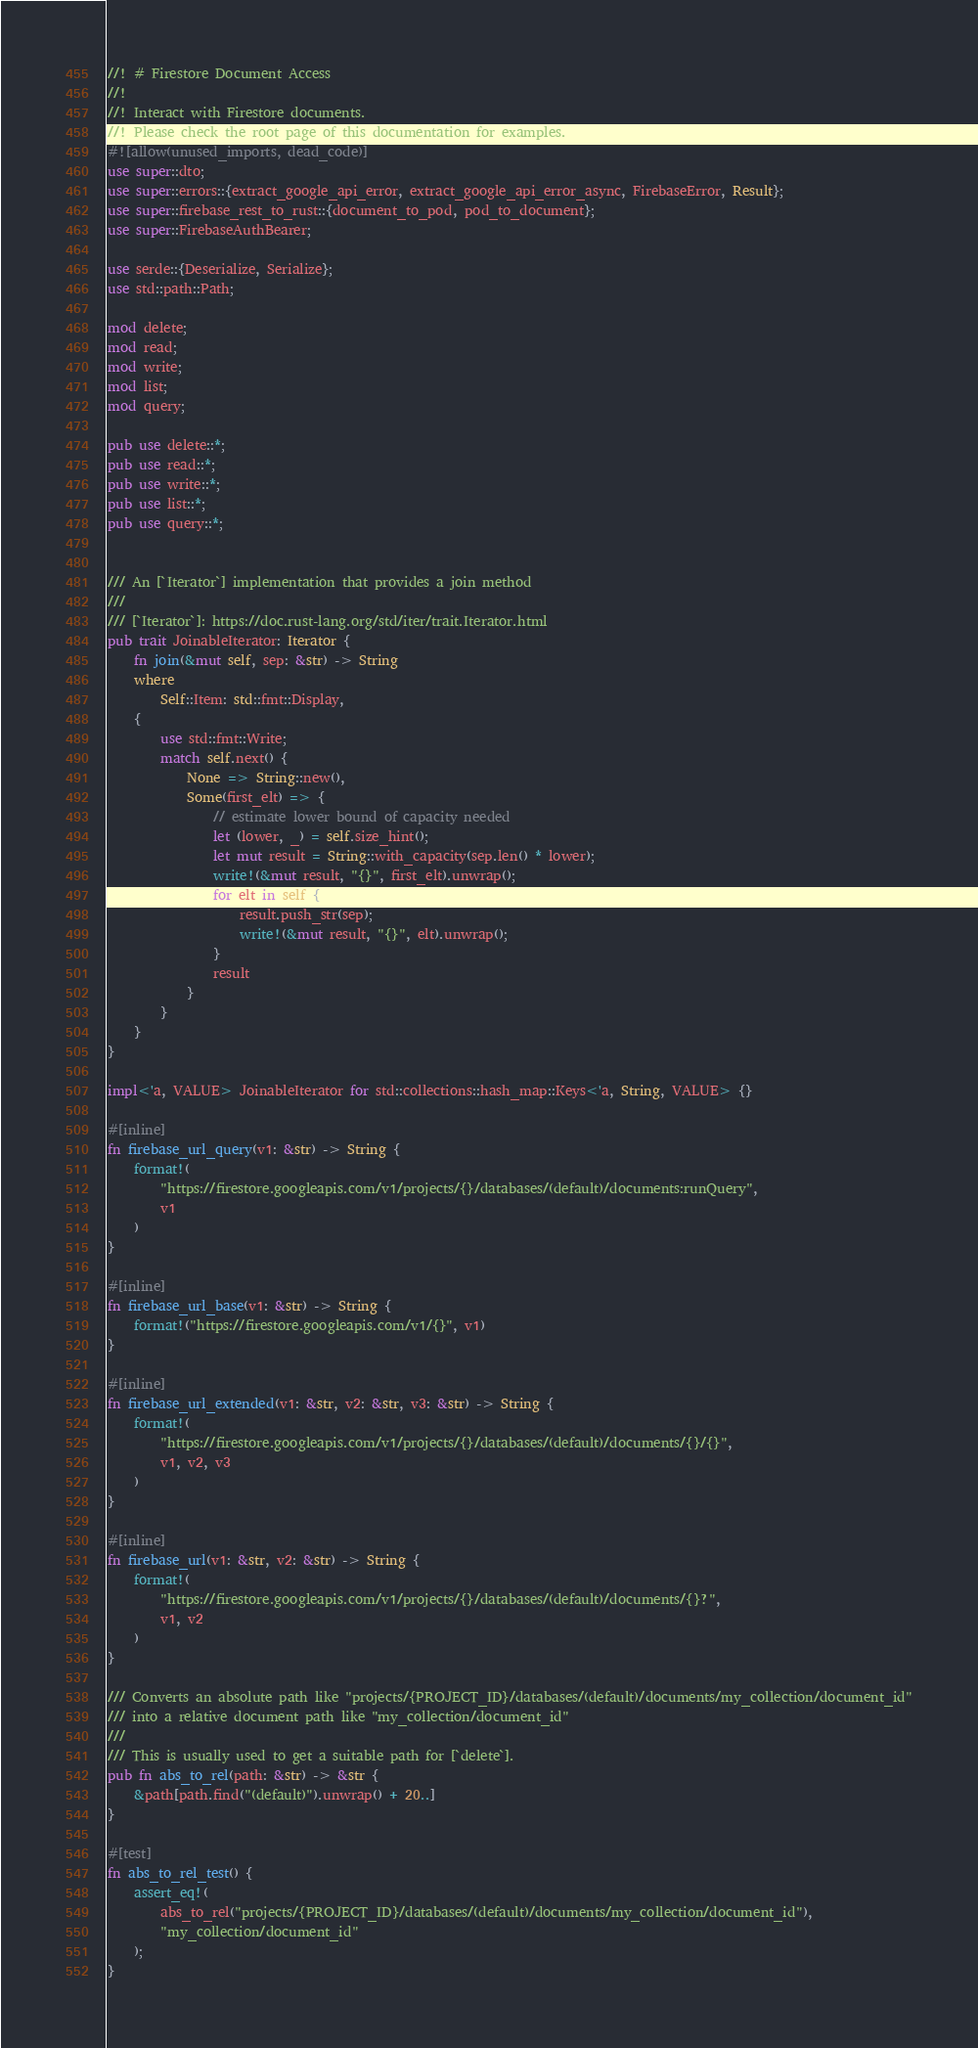<code> <loc_0><loc_0><loc_500><loc_500><_Rust_>//! # Firestore Document Access
//!
//! Interact with Firestore documents.
//! Please check the root page of this documentation for examples.
#![allow(unused_imports, dead_code)]
use super::dto;
use super::errors::{extract_google_api_error, extract_google_api_error_async, FirebaseError, Result};
use super::firebase_rest_to_rust::{document_to_pod, pod_to_document};
use super::FirebaseAuthBearer;

use serde::{Deserialize, Serialize};
use std::path::Path;

mod delete;
mod read;
mod write;
mod list;
mod query;

pub use delete::*;
pub use read::*;
pub use write::*;
pub use list::*;
pub use query::*;


/// An [`Iterator`] implementation that provides a join method
///
/// [`Iterator`]: https://doc.rust-lang.org/std/iter/trait.Iterator.html
pub trait JoinableIterator: Iterator {
    fn join(&mut self, sep: &str) -> String
    where
        Self::Item: std::fmt::Display,
    {
        use std::fmt::Write;
        match self.next() {
            None => String::new(),
            Some(first_elt) => {
                // estimate lower bound of capacity needed
                let (lower, _) = self.size_hint();
                let mut result = String::with_capacity(sep.len() * lower);
                write!(&mut result, "{}", first_elt).unwrap();
                for elt in self {
                    result.push_str(sep);
                    write!(&mut result, "{}", elt).unwrap();
                }
                result
            }
        }
    }
}

impl<'a, VALUE> JoinableIterator for std::collections::hash_map::Keys<'a, String, VALUE> {}

#[inline]
fn firebase_url_query(v1: &str) -> String {
    format!(
        "https://firestore.googleapis.com/v1/projects/{}/databases/(default)/documents:runQuery",
        v1
    )
}

#[inline]
fn firebase_url_base(v1: &str) -> String {
    format!("https://firestore.googleapis.com/v1/{}", v1)
}

#[inline]
fn firebase_url_extended(v1: &str, v2: &str, v3: &str) -> String {
    format!(
        "https://firestore.googleapis.com/v1/projects/{}/databases/(default)/documents/{}/{}",
        v1, v2, v3
    )
}

#[inline]
fn firebase_url(v1: &str, v2: &str) -> String {
    format!(
        "https://firestore.googleapis.com/v1/projects/{}/databases/(default)/documents/{}?",
        v1, v2
    )
}

/// Converts an absolute path like "projects/{PROJECT_ID}/databases/(default)/documents/my_collection/document_id"
/// into a relative document path like "my_collection/document_id"
///
/// This is usually used to get a suitable path for [`delete`].
pub fn abs_to_rel(path: &str) -> &str {
    &path[path.find("(default)").unwrap() + 20..]
}

#[test]
fn abs_to_rel_test() {
    assert_eq!(
        abs_to_rel("projects/{PROJECT_ID}/databases/(default)/documents/my_collection/document_id"),
        "my_collection/document_id"
    );
}
</code> 